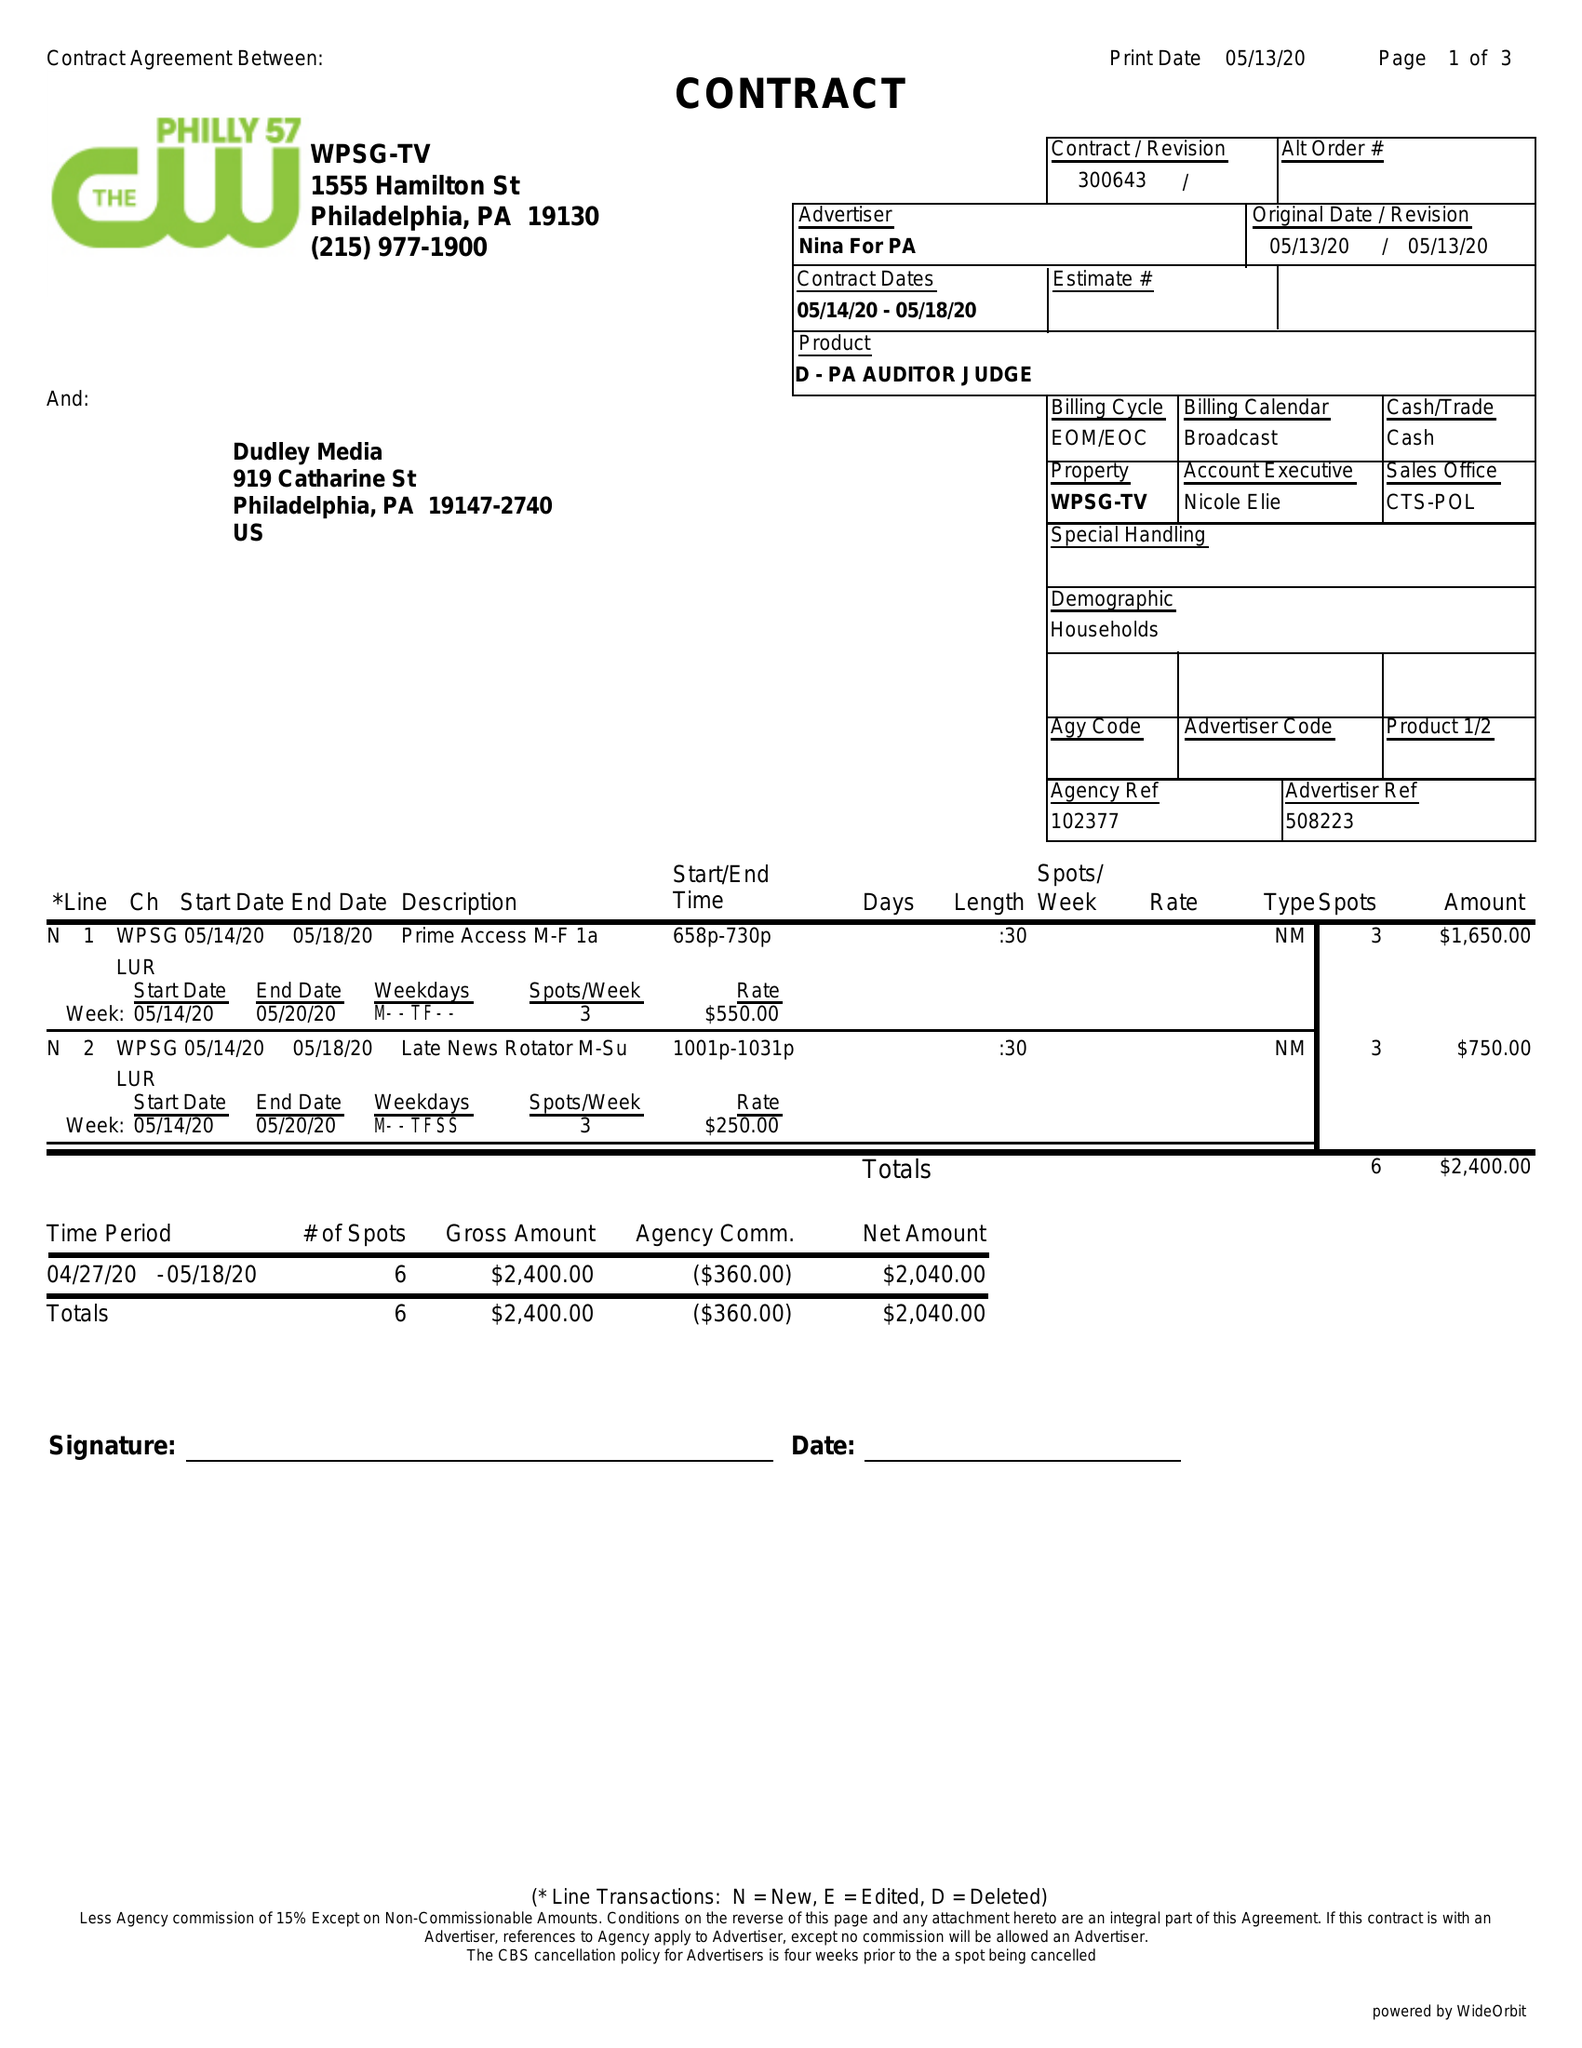What is the value for the flight_from?
Answer the question using a single word or phrase. 05/14/20 